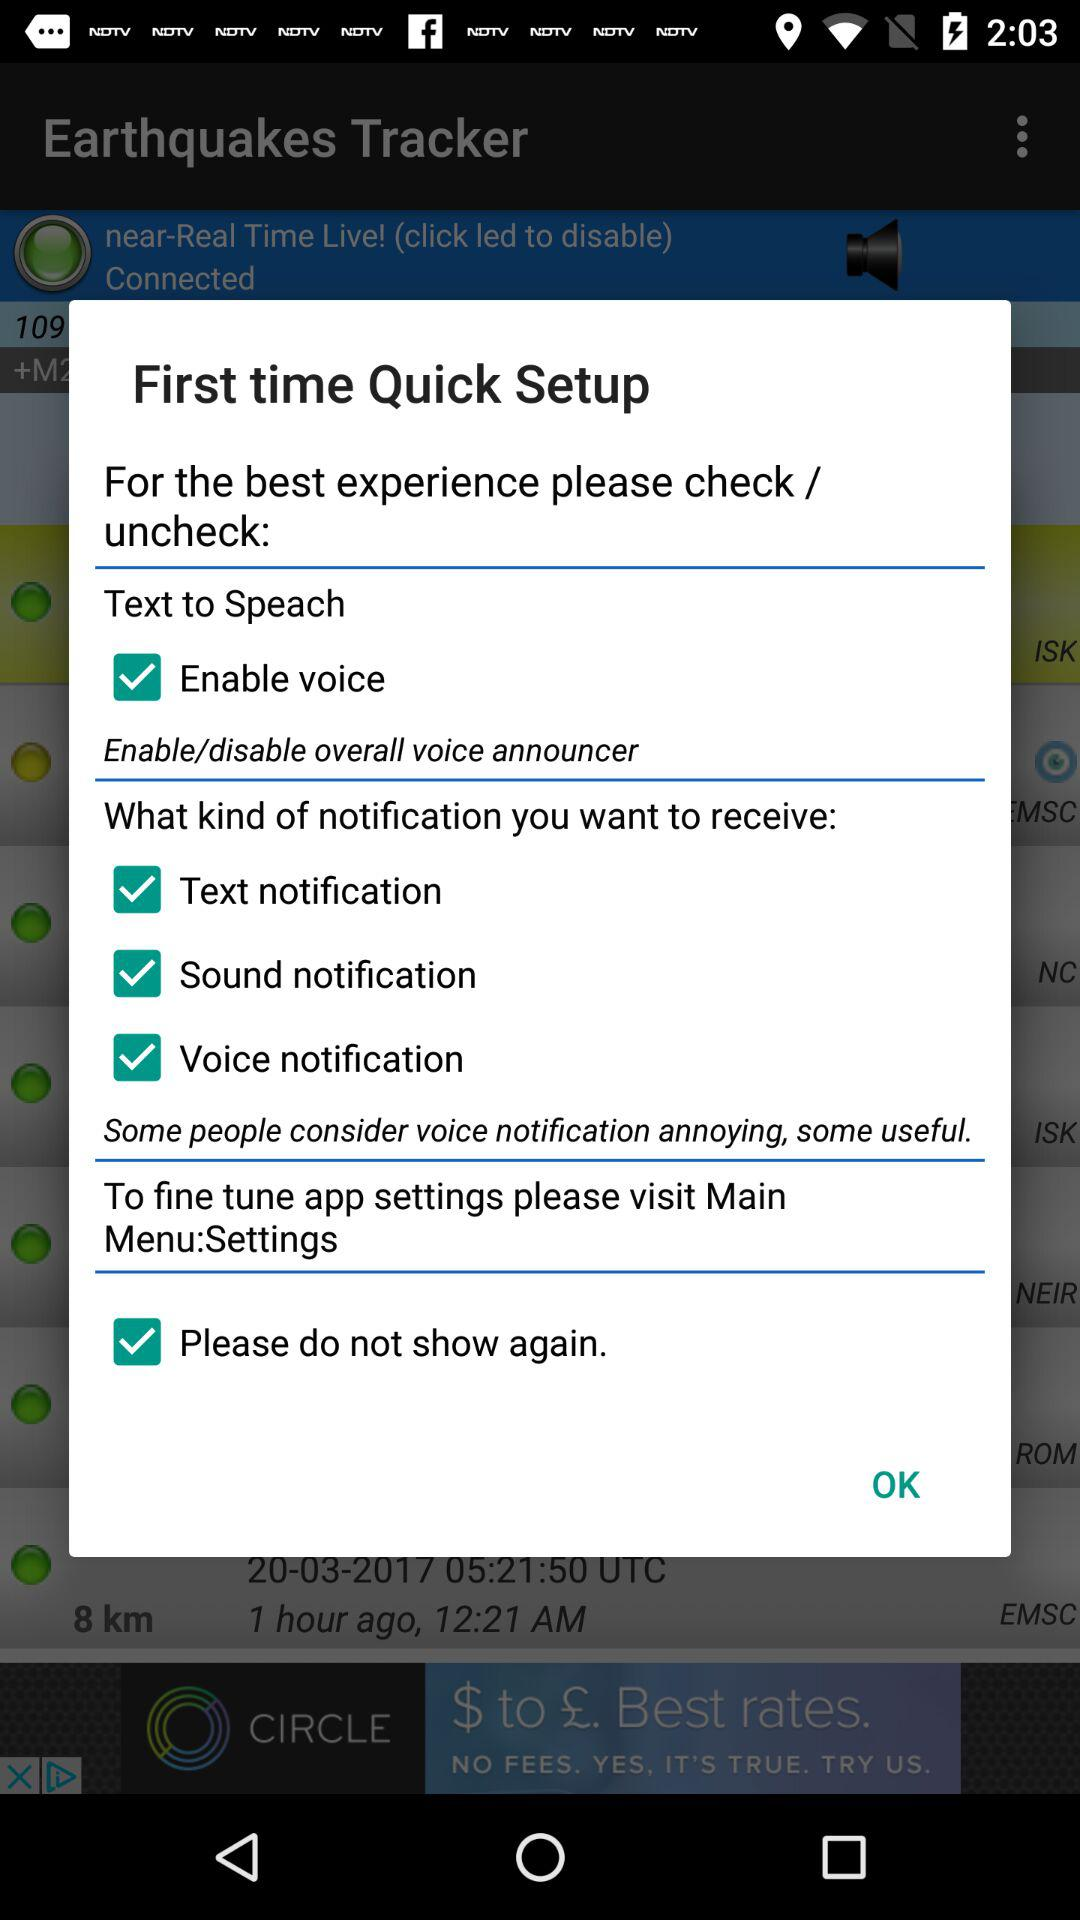What is the status for first time quick step up?
When the provided information is insufficient, respond with <no answer>. <no answer> 